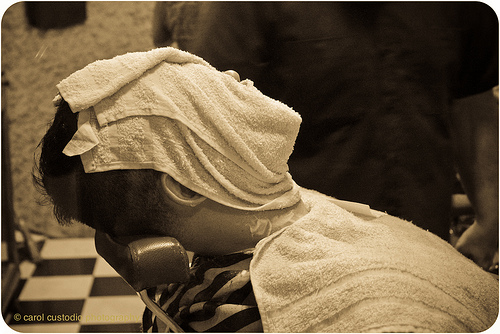<image>
Is there a man on the towel? No. The man is not positioned on the towel. They may be near each other, but the man is not supported by or resting on top of the towel. 